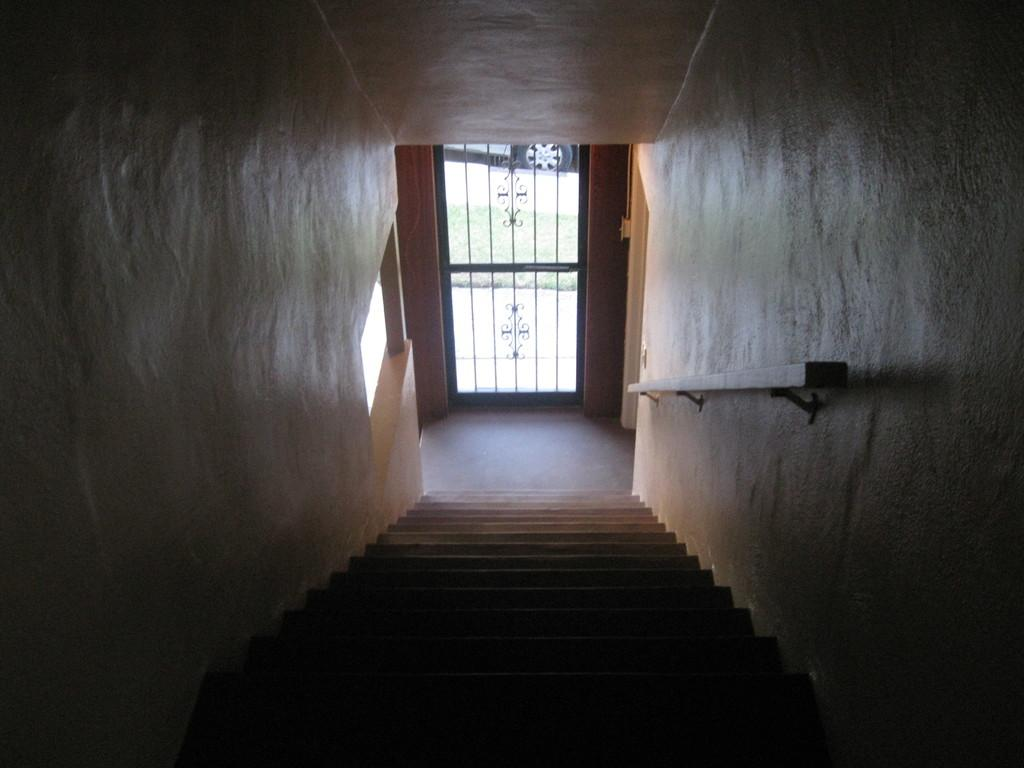What is the main feature in the foreground of the image? There is a staircase in the foreground of the image. What can be seen in the background of the image? There is a door visible in the background of the image, and a vehicle is parked on the ground. What type of music is the band playing on the trail in the image? There is no band or trail present in the image; it features a staircase, a door, and a parked vehicle. 